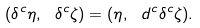<formula> <loc_0><loc_0><loc_500><loc_500>( \delta ^ { c } \eta , \ \delta ^ { c } \zeta ) = ( \eta , \ d ^ { c } \delta ^ { c } \zeta ) .</formula> 